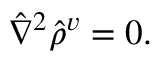<formula> <loc_0><loc_0><loc_500><loc_500>\hat { \nabla } ^ { 2 } \hat { \rho } ^ { v } = 0 .</formula> 